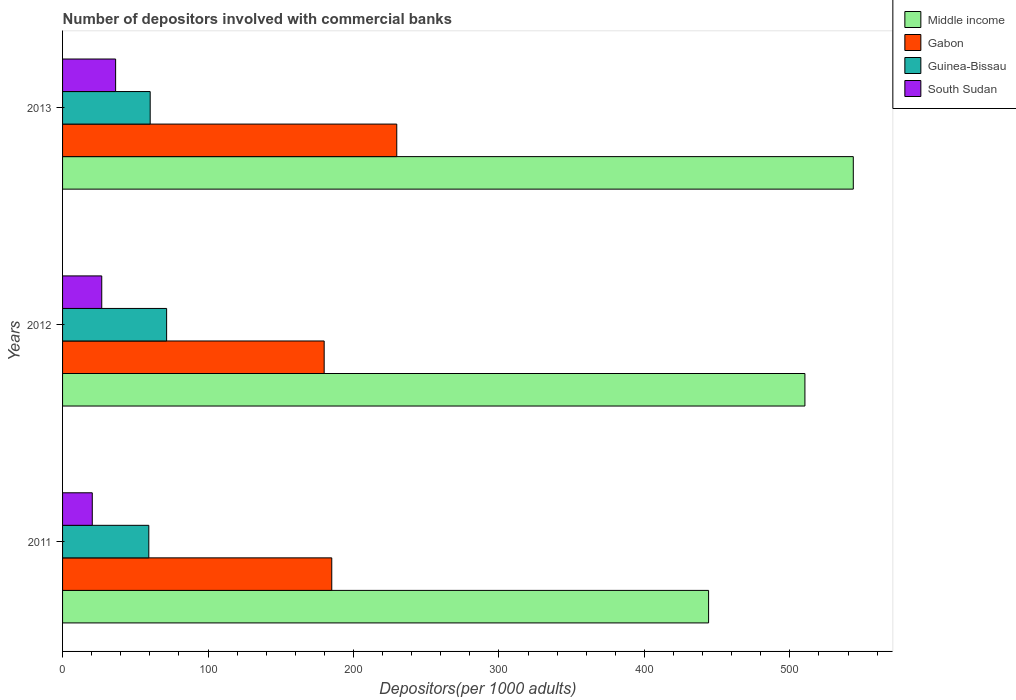Are the number of bars per tick equal to the number of legend labels?
Offer a very short reply. Yes. Are the number of bars on each tick of the Y-axis equal?
Offer a very short reply. Yes. How many bars are there on the 1st tick from the top?
Give a very brief answer. 4. How many bars are there on the 3rd tick from the bottom?
Provide a succinct answer. 4. In how many cases, is the number of bars for a given year not equal to the number of legend labels?
Your answer should be very brief. 0. What is the number of depositors involved with commercial banks in Middle income in 2013?
Provide a succinct answer. 543.59. Across all years, what is the maximum number of depositors involved with commercial banks in Middle income?
Offer a very short reply. 543.59. Across all years, what is the minimum number of depositors involved with commercial banks in Gabon?
Your answer should be compact. 179.84. What is the total number of depositors involved with commercial banks in Gabon in the graph?
Your response must be concise. 594.64. What is the difference between the number of depositors involved with commercial banks in South Sudan in 2012 and that in 2013?
Offer a terse response. -9.54. What is the difference between the number of depositors involved with commercial banks in Guinea-Bissau in 2013 and the number of depositors involved with commercial banks in Middle income in 2012?
Make the answer very short. -450.1. What is the average number of depositors involved with commercial banks in South Sudan per year?
Provide a succinct answer. 27.95. In the year 2012, what is the difference between the number of depositors involved with commercial banks in Middle income and number of depositors involved with commercial banks in Gabon?
Keep it short and to the point. 330.5. What is the ratio of the number of depositors involved with commercial banks in South Sudan in 2011 to that in 2012?
Your answer should be very brief. 0.76. Is the difference between the number of depositors involved with commercial banks in Middle income in 2011 and 2012 greater than the difference between the number of depositors involved with commercial banks in Gabon in 2011 and 2012?
Provide a short and direct response. No. What is the difference between the highest and the second highest number of depositors involved with commercial banks in Middle income?
Provide a short and direct response. 33.25. What is the difference between the highest and the lowest number of depositors involved with commercial banks in Guinea-Bissau?
Offer a very short reply. 12.25. In how many years, is the number of depositors involved with commercial banks in Middle income greater than the average number of depositors involved with commercial banks in Middle income taken over all years?
Offer a very short reply. 2. Is the sum of the number of depositors involved with commercial banks in Gabon in 2011 and 2013 greater than the maximum number of depositors involved with commercial banks in Middle income across all years?
Your response must be concise. No. Is it the case that in every year, the sum of the number of depositors involved with commercial banks in South Sudan and number of depositors involved with commercial banks in Middle income is greater than the sum of number of depositors involved with commercial banks in Gabon and number of depositors involved with commercial banks in Guinea-Bissau?
Offer a very short reply. Yes. What does the 1st bar from the top in 2012 represents?
Offer a very short reply. South Sudan. What does the 2nd bar from the bottom in 2011 represents?
Your answer should be compact. Gabon. Is it the case that in every year, the sum of the number of depositors involved with commercial banks in Guinea-Bissau and number of depositors involved with commercial banks in South Sudan is greater than the number of depositors involved with commercial banks in Gabon?
Your answer should be very brief. No. How many years are there in the graph?
Ensure brevity in your answer.  3. Does the graph contain grids?
Offer a terse response. No. Where does the legend appear in the graph?
Your answer should be compact. Top right. How are the legend labels stacked?
Keep it short and to the point. Vertical. What is the title of the graph?
Make the answer very short. Number of depositors involved with commercial banks. Does "Egypt, Arab Rep." appear as one of the legend labels in the graph?
Make the answer very short. No. What is the label or title of the X-axis?
Your response must be concise. Depositors(per 1000 adults). What is the Depositors(per 1000 adults) of Middle income in 2011?
Offer a terse response. 444.11. What is the Depositors(per 1000 adults) of Gabon in 2011?
Keep it short and to the point. 185.06. What is the Depositors(per 1000 adults) in Guinea-Bissau in 2011?
Make the answer very short. 59.29. What is the Depositors(per 1000 adults) of South Sudan in 2011?
Ensure brevity in your answer.  20.42. What is the Depositors(per 1000 adults) in Middle income in 2012?
Ensure brevity in your answer.  510.34. What is the Depositors(per 1000 adults) in Gabon in 2012?
Your response must be concise. 179.84. What is the Depositors(per 1000 adults) of Guinea-Bissau in 2012?
Ensure brevity in your answer.  71.54. What is the Depositors(per 1000 adults) in South Sudan in 2012?
Make the answer very short. 26.94. What is the Depositors(per 1000 adults) in Middle income in 2013?
Your answer should be very brief. 543.59. What is the Depositors(per 1000 adults) in Gabon in 2013?
Ensure brevity in your answer.  229.74. What is the Depositors(per 1000 adults) of Guinea-Bissau in 2013?
Keep it short and to the point. 60.23. What is the Depositors(per 1000 adults) of South Sudan in 2013?
Provide a short and direct response. 36.47. Across all years, what is the maximum Depositors(per 1000 adults) in Middle income?
Your answer should be very brief. 543.59. Across all years, what is the maximum Depositors(per 1000 adults) of Gabon?
Make the answer very short. 229.74. Across all years, what is the maximum Depositors(per 1000 adults) in Guinea-Bissau?
Keep it short and to the point. 71.54. Across all years, what is the maximum Depositors(per 1000 adults) of South Sudan?
Provide a short and direct response. 36.47. Across all years, what is the minimum Depositors(per 1000 adults) of Middle income?
Your answer should be compact. 444.11. Across all years, what is the minimum Depositors(per 1000 adults) of Gabon?
Your answer should be very brief. 179.84. Across all years, what is the minimum Depositors(per 1000 adults) of Guinea-Bissau?
Your answer should be compact. 59.29. Across all years, what is the minimum Depositors(per 1000 adults) in South Sudan?
Offer a terse response. 20.42. What is the total Depositors(per 1000 adults) of Middle income in the graph?
Give a very brief answer. 1498.04. What is the total Depositors(per 1000 adults) of Gabon in the graph?
Offer a terse response. 594.64. What is the total Depositors(per 1000 adults) of Guinea-Bissau in the graph?
Provide a short and direct response. 191.06. What is the total Depositors(per 1000 adults) of South Sudan in the graph?
Ensure brevity in your answer.  83.84. What is the difference between the Depositors(per 1000 adults) of Middle income in 2011 and that in 2012?
Provide a succinct answer. -66.23. What is the difference between the Depositors(per 1000 adults) in Gabon in 2011 and that in 2012?
Provide a succinct answer. 5.22. What is the difference between the Depositors(per 1000 adults) of Guinea-Bissau in 2011 and that in 2012?
Give a very brief answer. -12.25. What is the difference between the Depositors(per 1000 adults) in South Sudan in 2011 and that in 2012?
Offer a terse response. -6.51. What is the difference between the Depositors(per 1000 adults) in Middle income in 2011 and that in 2013?
Ensure brevity in your answer.  -99.48. What is the difference between the Depositors(per 1000 adults) in Gabon in 2011 and that in 2013?
Provide a succinct answer. -44.69. What is the difference between the Depositors(per 1000 adults) in Guinea-Bissau in 2011 and that in 2013?
Ensure brevity in your answer.  -0.94. What is the difference between the Depositors(per 1000 adults) of South Sudan in 2011 and that in 2013?
Provide a short and direct response. -16.05. What is the difference between the Depositors(per 1000 adults) in Middle income in 2012 and that in 2013?
Make the answer very short. -33.25. What is the difference between the Depositors(per 1000 adults) in Gabon in 2012 and that in 2013?
Make the answer very short. -49.9. What is the difference between the Depositors(per 1000 adults) of Guinea-Bissau in 2012 and that in 2013?
Make the answer very short. 11.31. What is the difference between the Depositors(per 1000 adults) in South Sudan in 2012 and that in 2013?
Give a very brief answer. -9.54. What is the difference between the Depositors(per 1000 adults) of Middle income in 2011 and the Depositors(per 1000 adults) of Gabon in 2012?
Provide a succinct answer. 264.27. What is the difference between the Depositors(per 1000 adults) of Middle income in 2011 and the Depositors(per 1000 adults) of Guinea-Bissau in 2012?
Offer a very short reply. 372.57. What is the difference between the Depositors(per 1000 adults) of Middle income in 2011 and the Depositors(per 1000 adults) of South Sudan in 2012?
Your answer should be compact. 417.17. What is the difference between the Depositors(per 1000 adults) in Gabon in 2011 and the Depositors(per 1000 adults) in Guinea-Bissau in 2012?
Your response must be concise. 113.52. What is the difference between the Depositors(per 1000 adults) of Gabon in 2011 and the Depositors(per 1000 adults) of South Sudan in 2012?
Offer a very short reply. 158.12. What is the difference between the Depositors(per 1000 adults) of Guinea-Bissau in 2011 and the Depositors(per 1000 adults) of South Sudan in 2012?
Provide a short and direct response. 32.35. What is the difference between the Depositors(per 1000 adults) in Middle income in 2011 and the Depositors(per 1000 adults) in Gabon in 2013?
Ensure brevity in your answer.  214.37. What is the difference between the Depositors(per 1000 adults) of Middle income in 2011 and the Depositors(per 1000 adults) of Guinea-Bissau in 2013?
Provide a short and direct response. 383.88. What is the difference between the Depositors(per 1000 adults) in Middle income in 2011 and the Depositors(per 1000 adults) in South Sudan in 2013?
Make the answer very short. 407.64. What is the difference between the Depositors(per 1000 adults) in Gabon in 2011 and the Depositors(per 1000 adults) in Guinea-Bissau in 2013?
Your answer should be very brief. 124.82. What is the difference between the Depositors(per 1000 adults) in Gabon in 2011 and the Depositors(per 1000 adults) in South Sudan in 2013?
Give a very brief answer. 148.58. What is the difference between the Depositors(per 1000 adults) of Guinea-Bissau in 2011 and the Depositors(per 1000 adults) of South Sudan in 2013?
Your response must be concise. 22.82. What is the difference between the Depositors(per 1000 adults) of Middle income in 2012 and the Depositors(per 1000 adults) of Gabon in 2013?
Keep it short and to the point. 280.59. What is the difference between the Depositors(per 1000 adults) in Middle income in 2012 and the Depositors(per 1000 adults) in Guinea-Bissau in 2013?
Ensure brevity in your answer.  450.1. What is the difference between the Depositors(per 1000 adults) in Middle income in 2012 and the Depositors(per 1000 adults) in South Sudan in 2013?
Make the answer very short. 473.86. What is the difference between the Depositors(per 1000 adults) in Gabon in 2012 and the Depositors(per 1000 adults) in Guinea-Bissau in 2013?
Ensure brevity in your answer.  119.61. What is the difference between the Depositors(per 1000 adults) of Gabon in 2012 and the Depositors(per 1000 adults) of South Sudan in 2013?
Offer a very short reply. 143.37. What is the difference between the Depositors(per 1000 adults) of Guinea-Bissau in 2012 and the Depositors(per 1000 adults) of South Sudan in 2013?
Keep it short and to the point. 35.06. What is the average Depositors(per 1000 adults) in Middle income per year?
Keep it short and to the point. 499.35. What is the average Depositors(per 1000 adults) of Gabon per year?
Your response must be concise. 198.21. What is the average Depositors(per 1000 adults) in Guinea-Bissau per year?
Your response must be concise. 63.69. What is the average Depositors(per 1000 adults) of South Sudan per year?
Ensure brevity in your answer.  27.95. In the year 2011, what is the difference between the Depositors(per 1000 adults) in Middle income and Depositors(per 1000 adults) in Gabon?
Make the answer very short. 259.05. In the year 2011, what is the difference between the Depositors(per 1000 adults) of Middle income and Depositors(per 1000 adults) of Guinea-Bissau?
Your answer should be compact. 384.82. In the year 2011, what is the difference between the Depositors(per 1000 adults) in Middle income and Depositors(per 1000 adults) in South Sudan?
Keep it short and to the point. 423.69. In the year 2011, what is the difference between the Depositors(per 1000 adults) in Gabon and Depositors(per 1000 adults) in Guinea-Bissau?
Provide a succinct answer. 125.77. In the year 2011, what is the difference between the Depositors(per 1000 adults) of Gabon and Depositors(per 1000 adults) of South Sudan?
Provide a succinct answer. 164.63. In the year 2011, what is the difference between the Depositors(per 1000 adults) of Guinea-Bissau and Depositors(per 1000 adults) of South Sudan?
Ensure brevity in your answer.  38.87. In the year 2012, what is the difference between the Depositors(per 1000 adults) of Middle income and Depositors(per 1000 adults) of Gabon?
Make the answer very short. 330.5. In the year 2012, what is the difference between the Depositors(per 1000 adults) in Middle income and Depositors(per 1000 adults) in Guinea-Bissau?
Make the answer very short. 438.8. In the year 2012, what is the difference between the Depositors(per 1000 adults) of Middle income and Depositors(per 1000 adults) of South Sudan?
Provide a succinct answer. 483.4. In the year 2012, what is the difference between the Depositors(per 1000 adults) of Gabon and Depositors(per 1000 adults) of Guinea-Bissau?
Make the answer very short. 108.3. In the year 2012, what is the difference between the Depositors(per 1000 adults) of Gabon and Depositors(per 1000 adults) of South Sudan?
Your answer should be compact. 152.9. In the year 2012, what is the difference between the Depositors(per 1000 adults) in Guinea-Bissau and Depositors(per 1000 adults) in South Sudan?
Ensure brevity in your answer.  44.6. In the year 2013, what is the difference between the Depositors(per 1000 adults) in Middle income and Depositors(per 1000 adults) in Gabon?
Offer a very short reply. 313.85. In the year 2013, what is the difference between the Depositors(per 1000 adults) in Middle income and Depositors(per 1000 adults) in Guinea-Bissau?
Offer a very short reply. 483.36. In the year 2013, what is the difference between the Depositors(per 1000 adults) in Middle income and Depositors(per 1000 adults) in South Sudan?
Keep it short and to the point. 507.12. In the year 2013, what is the difference between the Depositors(per 1000 adults) of Gabon and Depositors(per 1000 adults) of Guinea-Bissau?
Provide a succinct answer. 169.51. In the year 2013, what is the difference between the Depositors(per 1000 adults) of Gabon and Depositors(per 1000 adults) of South Sudan?
Offer a very short reply. 193.27. In the year 2013, what is the difference between the Depositors(per 1000 adults) in Guinea-Bissau and Depositors(per 1000 adults) in South Sudan?
Your answer should be very brief. 23.76. What is the ratio of the Depositors(per 1000 adults) in Middle income in 2011 to that in 2012?
Your answer should be compact. 0.87. What is the ratio of the Depositors(per 1000 adults) in Guinea-Bissau in 2011 to that in 2012?
Offer a very short reply. 0.83. What is the ratio of the Depositors(per 1000 adults) of South Sudan in 2011 to that in 2012?
Ensure brevity in your answer.  0.76. What is the ratio of the Depositors(per 1000 adults) in Middle income in 2011 to that in 2013?
Provide a short and direct response. 0.82. What is the ratio of the Depositors(per 1000 adults) of Gabon in 2011 to that in 2013?
Your answer should be very brief. 0.81. What is the ratio of the Depositors(per 1000 adults) in Guinea-Bissau in 2011 to that in 2013?
Provide a succinct answer. 0.98. What is the ratio of the Depositors(per 1000 adults) of South Sudan in 2011 to that in 2013?
Provide a succinct answer. 0.56. What is the ratio of the Depositors(per 1000 adults) in Middle income in 2012 to that in 2013?
Give a very brief answer. 0.94. What is the ratio of the Depositors(per 1000 adults) in Gabon in 2012 to that in 2013?
Your answer should be very brief. 0.78. What is the ratio of the Depositors(per 1000 adults) of Guinea-Bissau in 2012 to that in 2013?
Your answer should be very brief. 1.19. What is the ratio of the Depositors(per 1000 adults) of South Sudan in 2012 to that in 2013?
Your response must be concise. 0.74. What is the difference between the highest and the second highest Depositors(per 1000 adults) in Middle income?
Ensure brevity in your answer.  33.25. What is the difference between the highest and the second highest Depositors(per 1000 adults) of Gabon?
Your response must be concise. 44.69. What is the difference between the highest and the second highest Depositors(per 1000 adults) in Guinea-Bissau?
Make the answer very short. 11.31. What is the difference between the highest and the second highest Depositors(per 1000 adults) in South Sudan?
Keep it short and to the point. 9.54. What is the difference between the highest and the lowest Depositors(per 1000 adults) of Middle income?
Provide a short and direct response. 99.48. What is the difference between the highest and the lowest Depositors(per 1000 adults) in Gabon?
Offer a very short reply. 49.9. What is the difference between the highest and the lowest Depositors(per 1000 adults) of Guinea-Bissau?
Your response must be concise. 12.25. What is the difference between the highest and the lowest Depositors(per 1000 adults) of South Sudan?
Your answer should be compact. 16.05. 